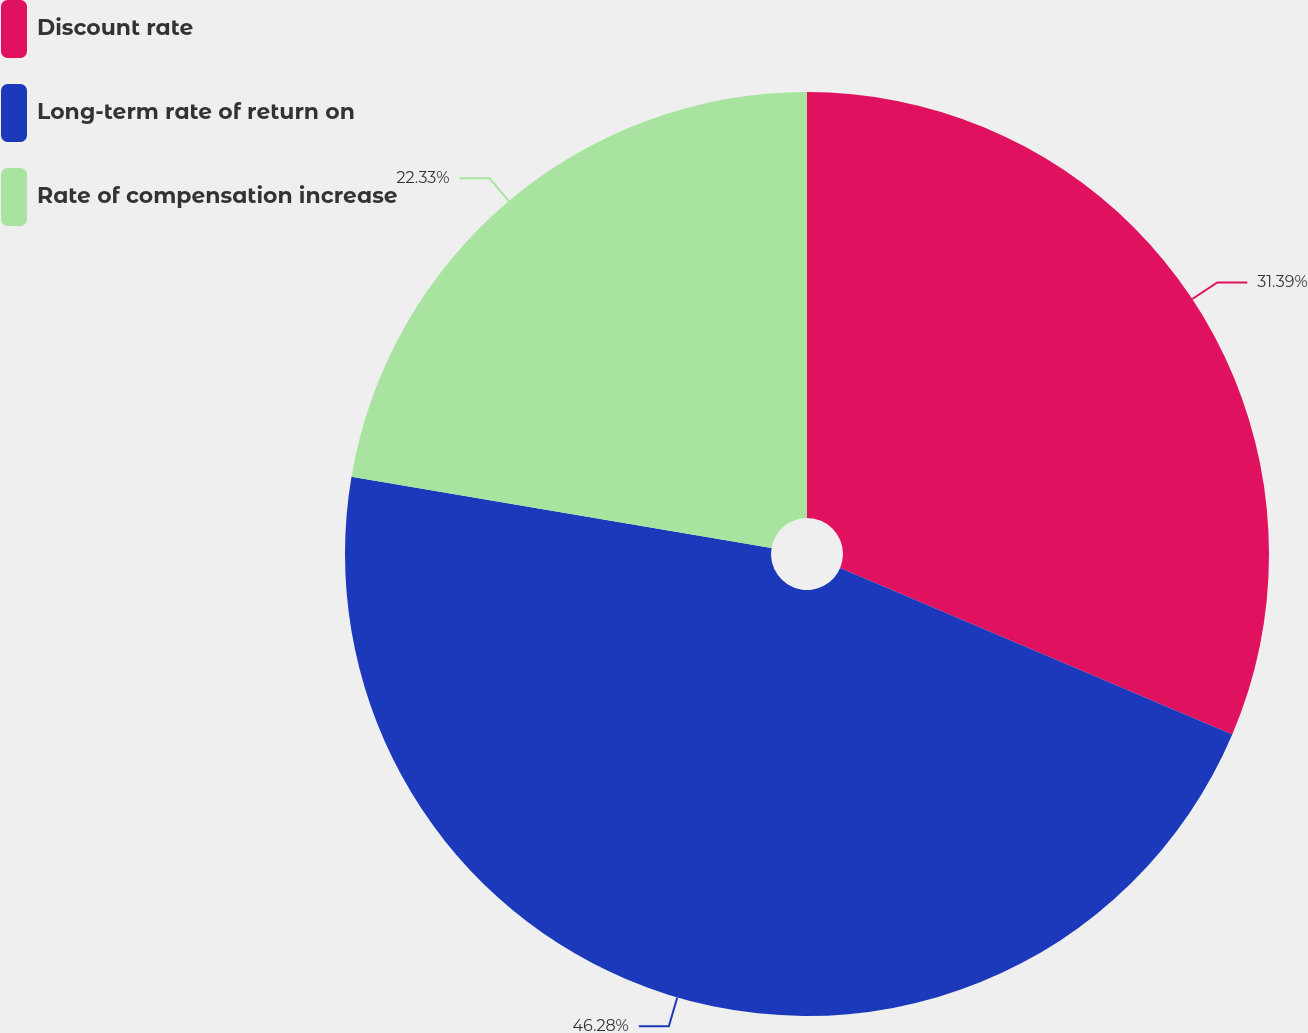<chart> <loc_0><loc_0><loc_500><loc_500><pie_chart><fcel>Discount rate<fcel>Long-term rate of return on<fcel>Rate of compensation increase<nl><fcel>31.39%<fcel>46.28%<fcel>22.33%<nl></chart> 